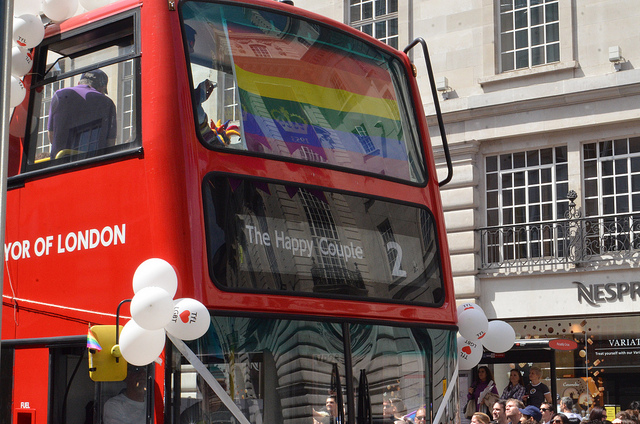Read all the text in this image. LONDON OF YOR The Happy NESPR VARIA 2 COUPLE 